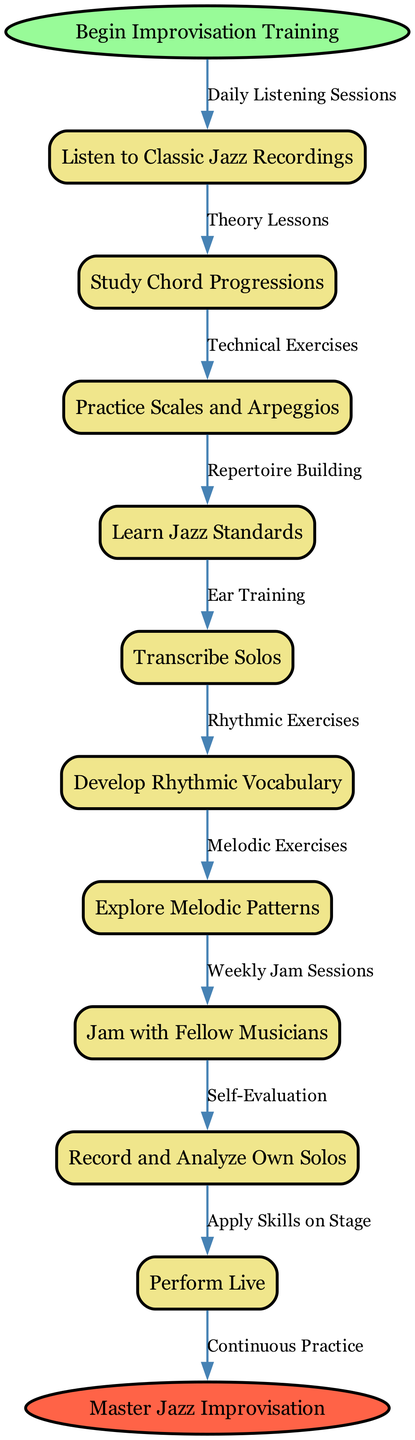What is the starting point of the diagram? The starting point is indicated by the 'start' node in the flowchart, labeled 'Begin Improvisation Training'. This is the initial action that signifies the commencement of the process.
Answer: Begin Improvisation Training How many total nodes are present in the diagram? By counting the 'nodes' section, we can see there are 10 distinct nodes representing various activities in the training workflow.
Answer: 10 Which node comes after "Study Chord Progressions"? Following "Study Chord Progressions," the next node is "Practice Scales and Arpeggios." This is derived from the order of nodes connected by edges in the flowchart.
Answer: Practice Scales and Arpeggios What kind of exercises are associated with "Develop Rhythmic Vocabulary"? The edge from "Develop Rhythmic Vocabulary" points to "Rhythmic Exercises," indicating that rhythmic exercises are related to developing a rhythmic vocabulary in the teaching workflow.
Answer: Rhythmic Exercises What is the relationship between "Jam with Fellow Musicians" and the performing stage? "Jam with Fellow Musicians" is a practice step that leads to an eventual performance, as indicated by its connection to "Record and Analyze Own Solos," and subsequently to "Perform Live," showing the progression toward public performance.
Answer: Leads to performance Which activity occurs last in the flow of the diagram? The final activity in the flowchart is represented by the 'end' node, which states 'Master Jazz Improvisation', signifying the goal that concludes the entire training process.
Answer: Master Jazz Improvisation How is "Listen to Classic Jazz Recordings" related to the overall workflow? "Listen to Classic Jazz Recordings" is the first node, connected to "Daily Listening Sessions," and sets the foundation for other activities, indicating its importance as an initial strategy in the flow.
Answer: Initial strategy What does the edge labeled "Continuous Practice" connect? This edge connects the last activity node, which is "Record and Analyze Own Solos," to the end node, indicating that continuous practice is a critical aspect leading towards mastering jazz improvisation.
Answer: Record and Analyze Own Solos to Master Jazz Improvisation 